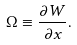Convert formula to latex. <formula><loc_0><loc_0><loc_500><loc_500>\Omega \equiv \frac { \partial W } { \partial x } .</formula> 